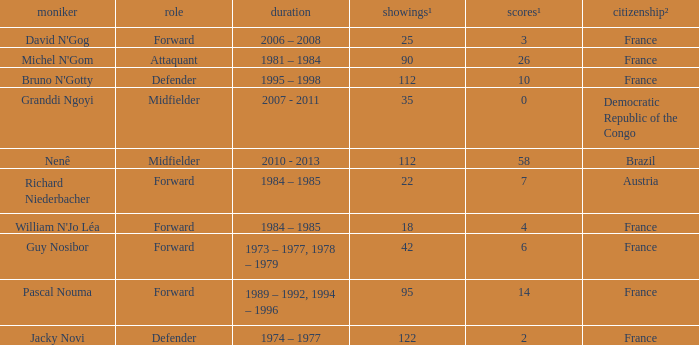List the number of active years for attaquant. 1981 – 1984. 